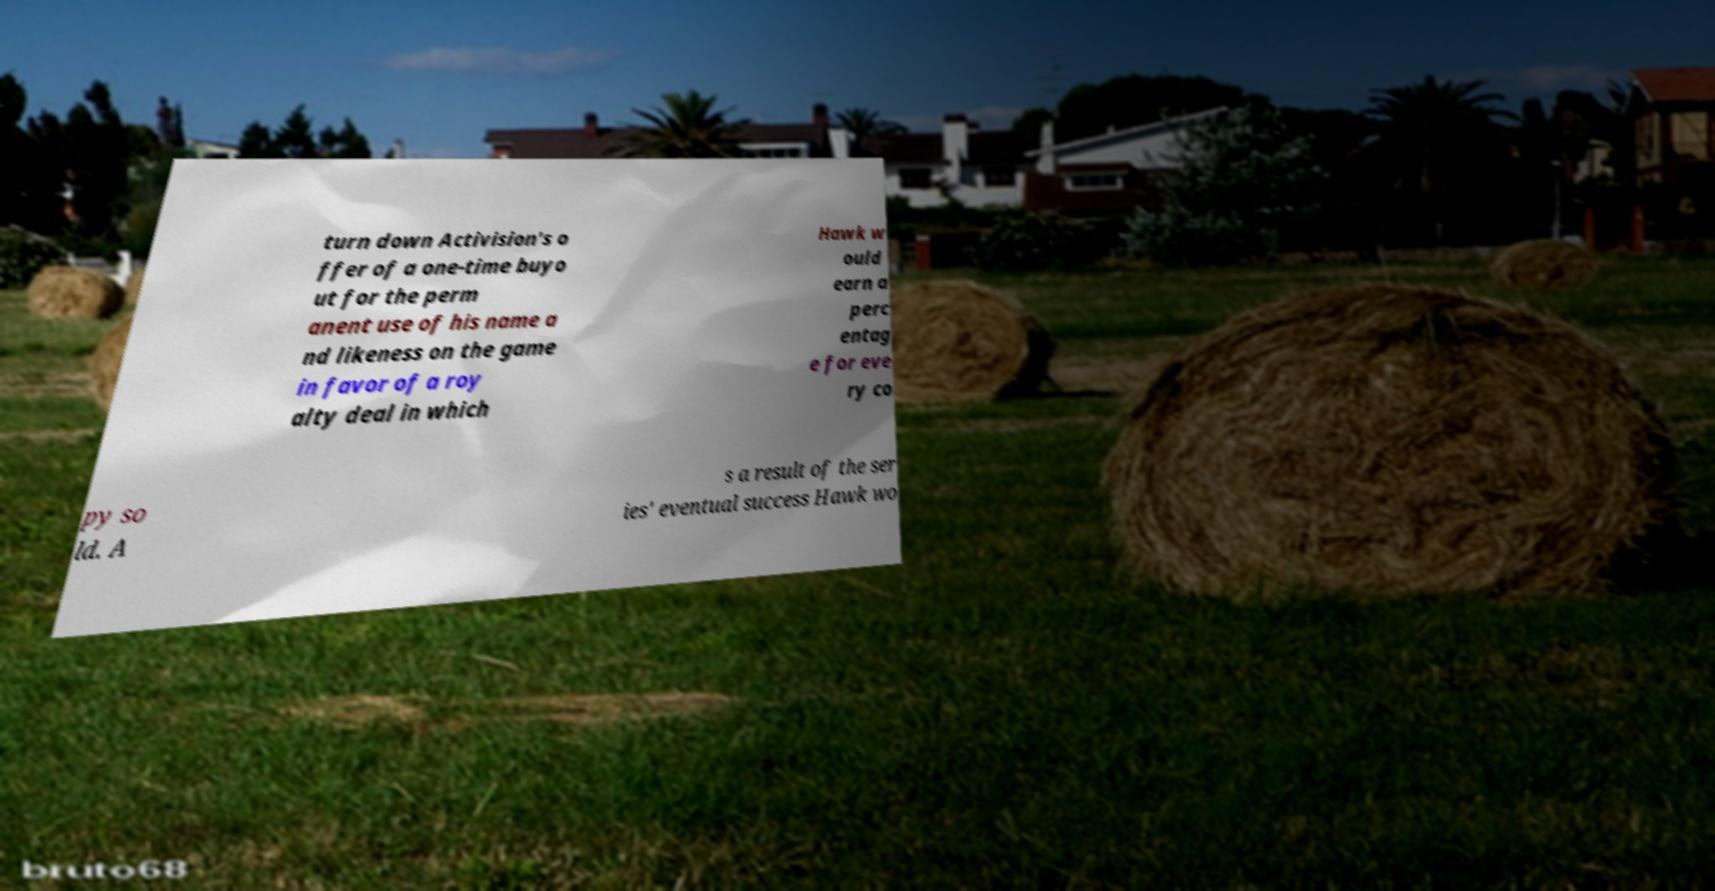Please identify and transcribe the text found in this image. turn down Activision's o ffer of a one-time buyo ut for the perm anent use of his name a nd likeness on the game in favor of a roy alty deal in which Hawk w ould earn a perc entag e for eve ry co py so ld. A s a result of the ser ies' eventual success Hawk wo 